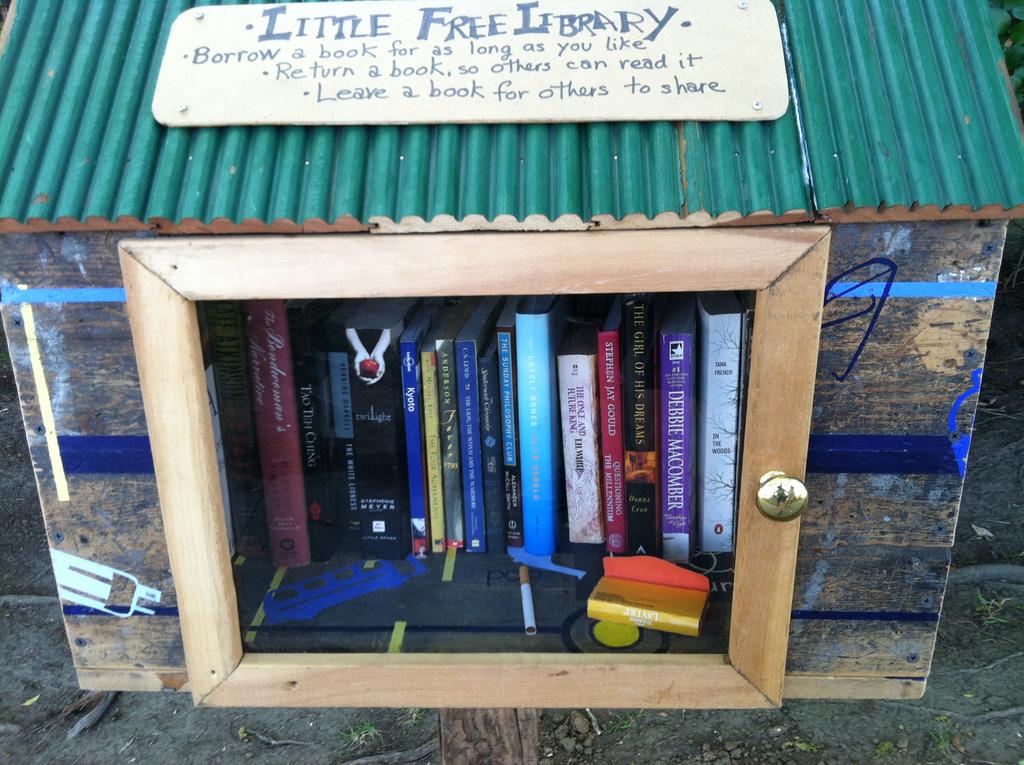What is the title of the thick black book?
Ensure brevity in your answer.  Twilight. How long can i keep the books?
Your response must be concise. As long as you like. 